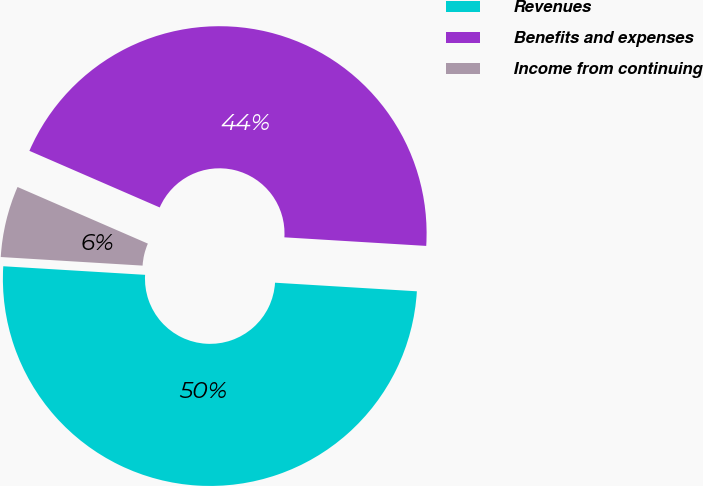<chart> <loc_0><loc_0><loc_500><loc_500><pie_chart><fcel>Revenues<fcel>Benefits and expenses<fcel>Income from continuing<nl><fcel>50.0%<fcel>44.44%<fcel>5.56%<nl></chart> 